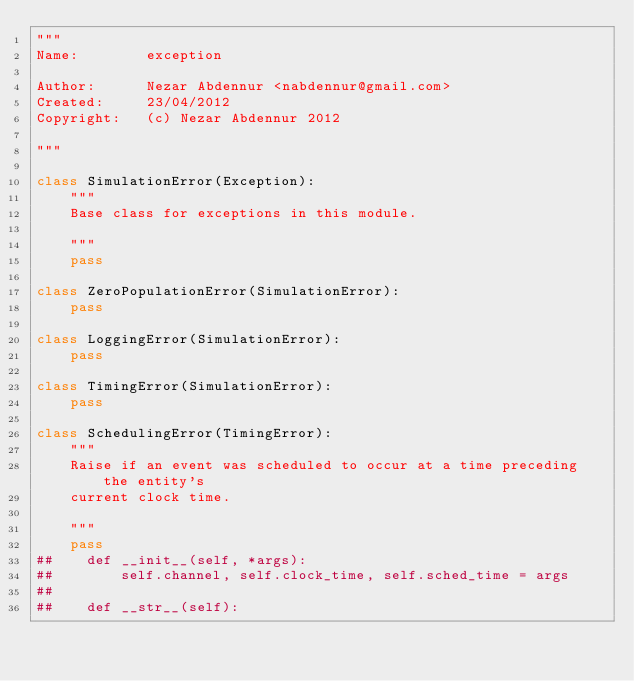Convert code to text. <code><loc_0><loc_0><loc_500><loc_500><_Python_>"""
Name:        exception

Author:      Nezar Abdennur <nabdennur@gmail.com>
Created:     23/04/2012
Copyright:   (c) Nezar Abdennur 2012

"""

class SimulationError(Exception):
    """
    Base class for exceptions in this module.

    """
    pass

class ZeroPopulationError(SimulationError):
    pass

class LoggingError(SimulationError):
    pass

class TimingError(SimulationError):
    pass

class SchedulingError(TimingError):
    """
    Raise if an event was scheduled to occur at a time preceding the entity's
    current clock time.

    """
    pass
##    def __init__(self, *args):
##        self.channel, self.clock_time, self.sched_time = args
##
##    def __str__(self):</code> 